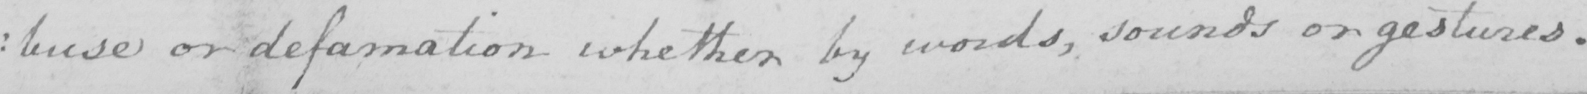Please transcribe the handwritten text in this image. : buse or defamation whether by words , sounds or gestures . 